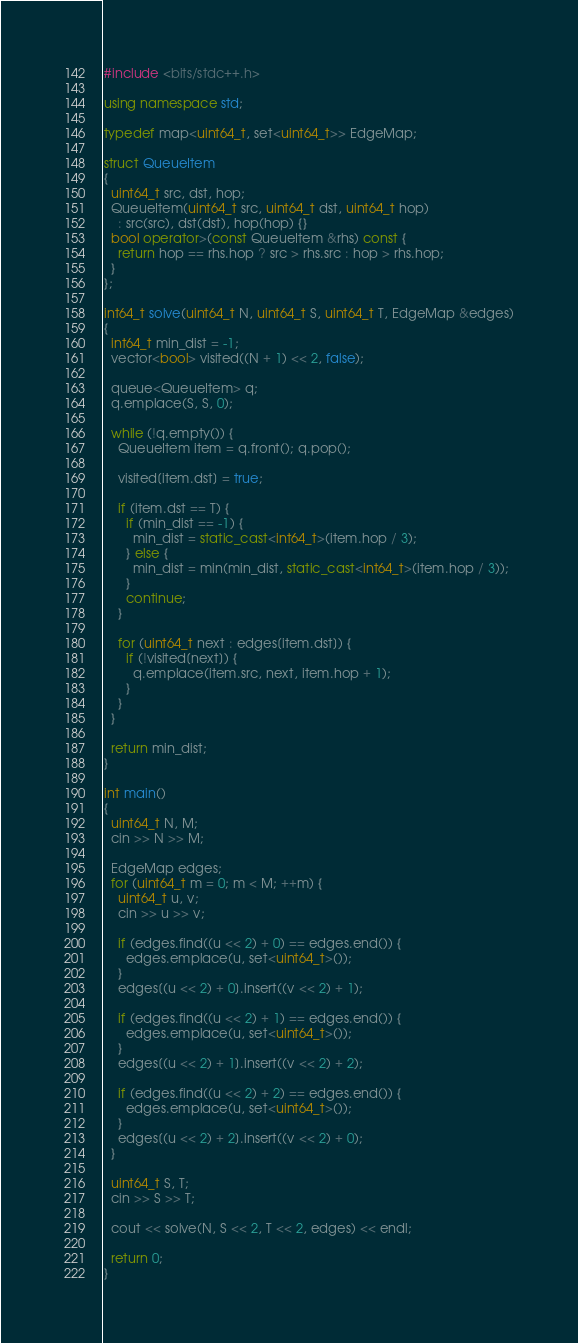Convert code to text. <code><loc_0><loc_0><loc_500><loc_500><_C++_>#include <bits/stdc++.h>

using namespace std;

typedef map<uint64_t, set<uint64_t>> EdgeMap;

struct QueueItem
{
  uint64_t src, dst, hop;
  QueueItem(uint64_t src, uint64_t dst, uint64_t hop)
    : src(src), dst(dst), hop(hop) {}
  bool operator>(const QueueItem &rhs) const {
    return hop == rhs.hop ? src > rhs.src : hop > rhs.hop;
  }
};

int64_t solve(uint64_t N, uint64_t S, uint64_t T, EdgeMap &edges)
{
  int64_t min_dist = -1;
  vector<bool> visited((N + 1) << 2, false);
  
  queue<QueueItem> q;
  q.emplace(S, S, 0);
  
  while (!q.empty()) {
    QueueItem item = q.front(); q.pop();
    
    visited[item.dst] = true;
    
    if (item.dst == T) {
      if (min_dist == -1) {
        min_dist = static_cast<int64_t>(item.hop / 3);
      } else {
        min_dist = min(min_dist, static_cast<int64_t>(item.hop / 3));
      }
      continue;
    }
    
    for (uint64_t next : edges[item.dst]) {
      if (!visited[next]) {
        q.emplace(item.src, next, item.hop + 1);
      }
    }
  }
  
  return min_dist;
}

int main()
{
  uint64_t N, M;
  cin >> N >> M;
  
  EdgeMap edges;
  for (uint64_t m = 0; m < M; ++m) {
    uint64_t u, v;
    cin >> u >> v;
    
    if (edges.find((u << 2) + 0) == edges.end()) {
      edges.emplace(u, set<uint64_t>());
    }
    edges[(u << 2) + 0].insert((v << 2) + 1);
    
    if (edges.find((u << 2) + 1) == edges.end()) {
      edges.emplace(u, set<uint64_t>());
    }
    edges[(u << 2) + 1].insert((v << 2) + 2);
    
    if (edges.find((u << 2) + 2) == edges.end()) {
      edges.emplace(u, set<uint64_t>());
    }
    edges[(u << 2) + 2].insert((v << 2) + 0);
  }
  
  uint64_t S, T;
  cin >> S >> T;
  
  cout << solve(N, S << 2, T << 2, edges) << endl;
  
  return 0;
}</code> 